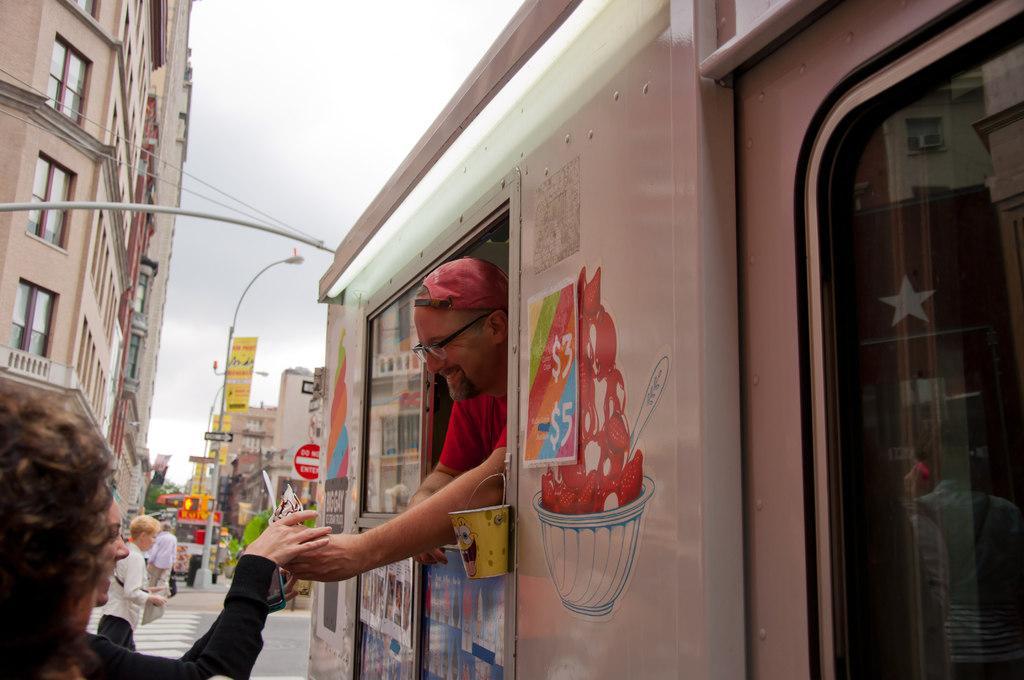How would you summarize this image in a sentence or two? This picture is clicked outside the city. In front of the picture, the man in red T-shirt is in the white vehicle. He is smiling and trying to give something to the woman who is wearing a black T-shirt. She is also smiling. Beside her, we see people walking on the road. Beside them, we see street lights and yellow color boards with some text written on it. There are buildings in the background. At the top of the picture, we see the sky. 